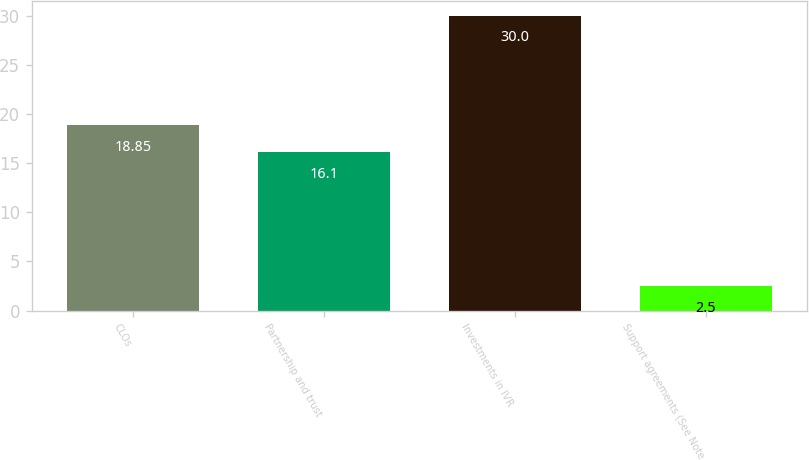Convert chart. <chart><loc_0><loc_0><loc_500><loc_500><bar_chart><fcel>CLOs<fcel>Partnership and trust<fcel>Investments in IVR<fcel>Support agreements (See Note<nl><fcel>18.85<fcel>16.1<fcel>30<fcel>2.5<nl></chart> 